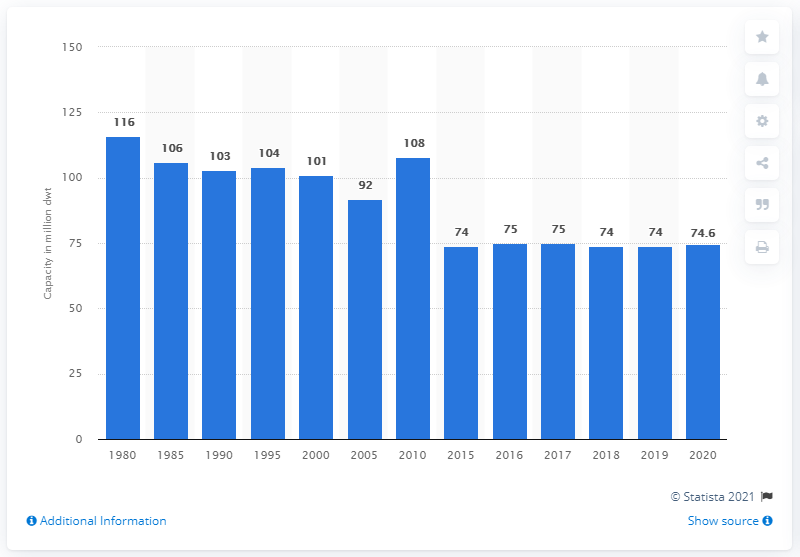Point out several critical features in this image. The world's general cargo ship fleet had a capacity of 74.6 in 2020. 